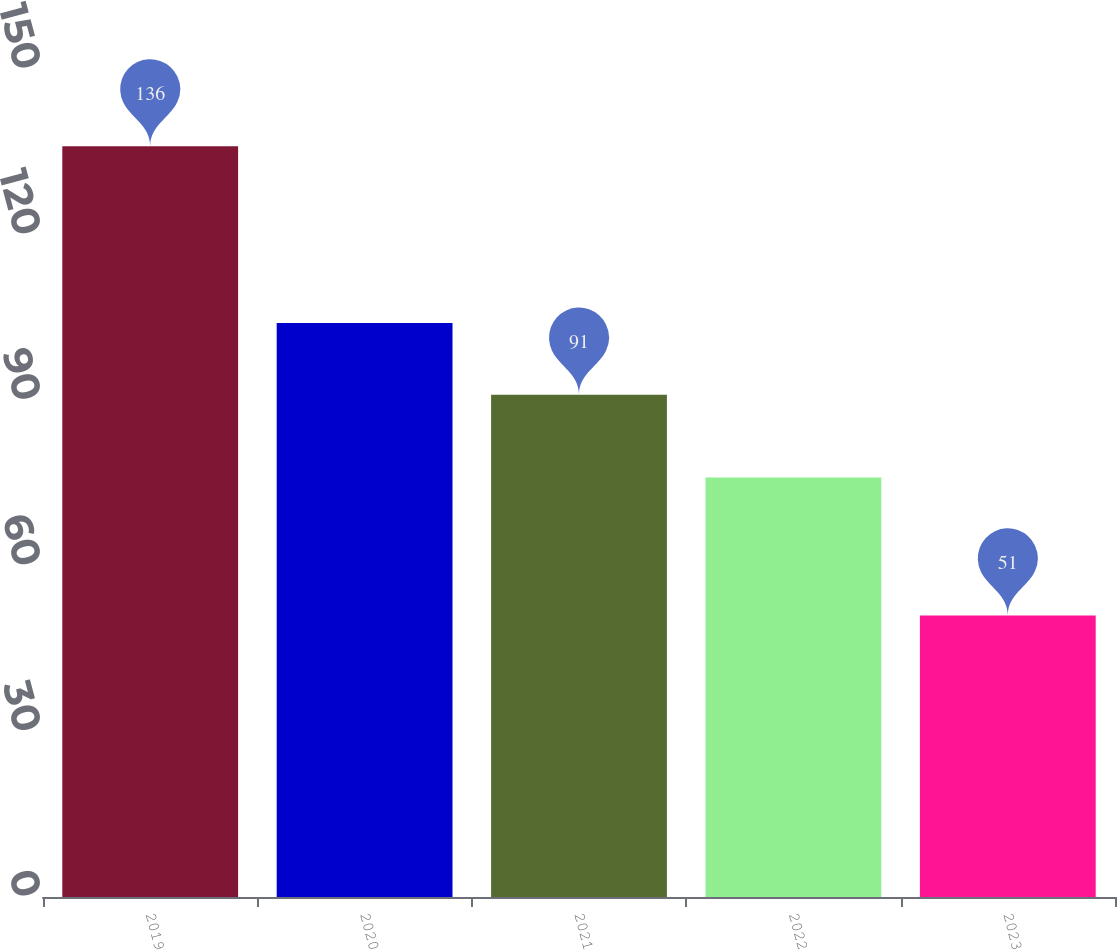Convert chart. <chart><loc_0><loc_0><loc_500><loc_500><bar_chart><fcel>2019<fcel>2020<fcel>2021<fcel>2022<fcel>2023<nl><fcel>136<fcel>104<fcel>91<fcel>76<fcel>51<nl></chart> 